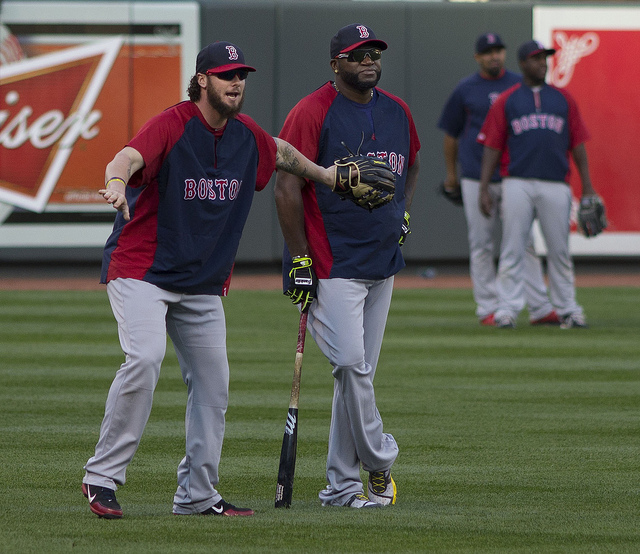<image>What number Jersey is the player furthest to the right wearing? It is unknown what number Jersey the player furthest to the right is wearing. Where is the soccer ball? There is no soccer ball in the image. Where is the soccer ball? There is no soccer ball in the image. It may have been taken away or hidden. What number Jersey is the player furthest to the right wearing? I don't know what number jersey the player furthest to the right is wearing. It can be any number between 0, 8, 30, 15, and 1. 